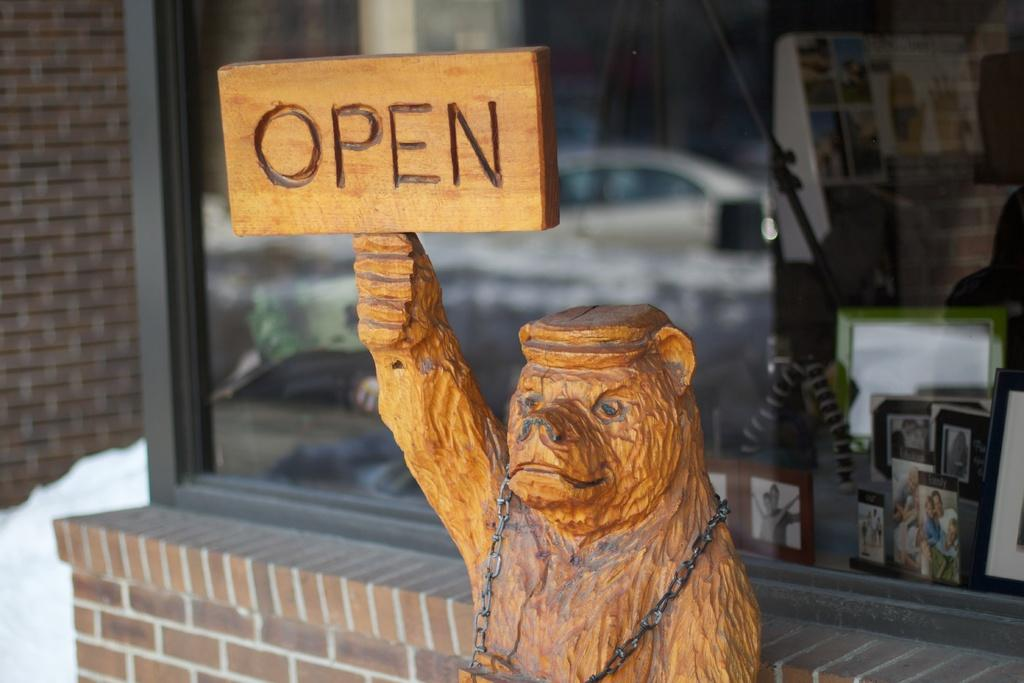What is located in front of the store in the image? There is a sculpture in front of the store. What is the sculpture holding in its hand? The sculpture is holding an open board in its hand. What type of clover is growing on the sculpture's head in the image? There is no clover present on the sculpture's head in the image. 